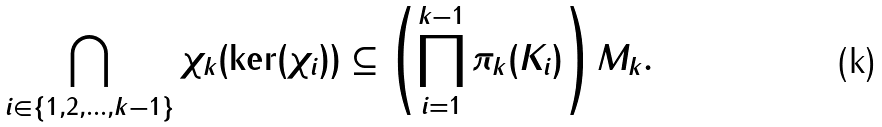<formula> <loc_0><loc_0><loc_500><loc_500>\bigcap _ { i \in \{ 1 , 2 , \dots , k - 1 \} } \chi _ { k } ( \ker ( \chi _ { i } ) ) \subseteq \left ( \prod _ { i = 1 } ^ { k - 1 } \pi _ { k } ( K _ { i } ) \right ) M _ { k } .</formula> 